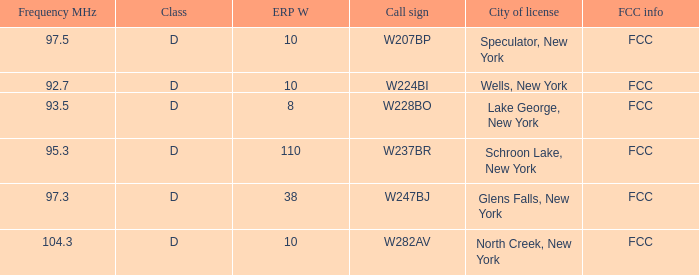Name the average ERP W and call sign of w237br 110.0. 